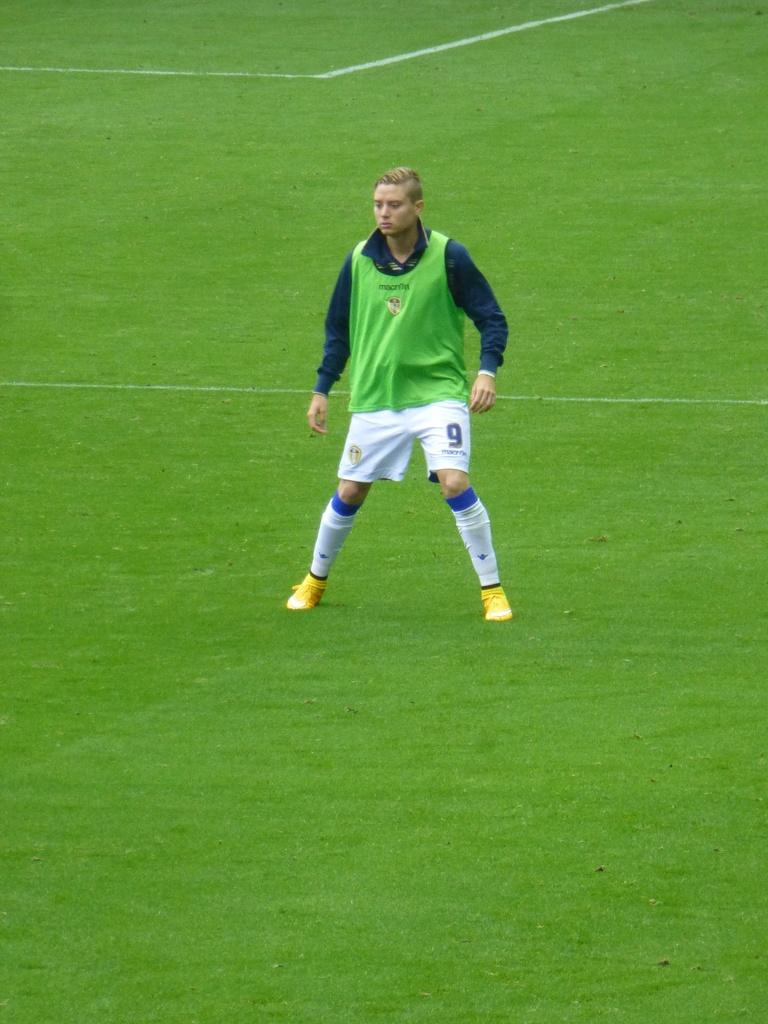What is the main subject of the image? There is a person standing in the center of the image. What type of surface is visible at the bottom of the image? There is grass at the bottom of the image. Can you tell me who the creator of the dock is in the image? There is no dock present in the image, so it is not possible to determine who the creator might be. 